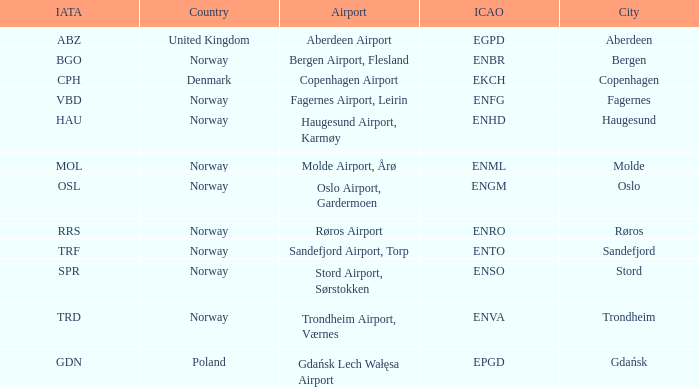What Airport's ICAO is ENTO? Sandefjord Airport, Torp. 